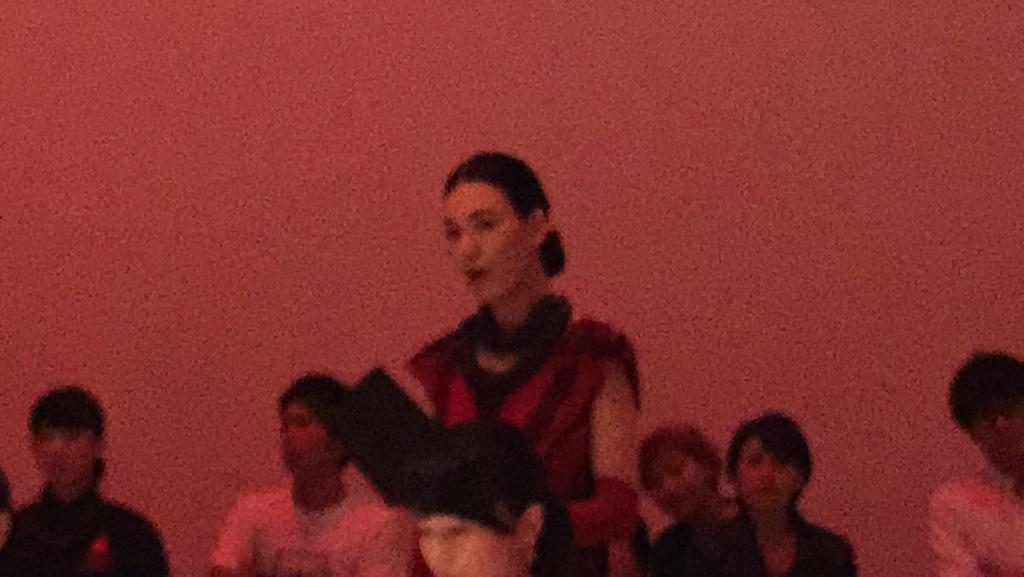What can be seen in the image? There is a group of people in the image, including a woman standing. What color is the background of the image? The background of the image is red. How is the image quality? The image is slightly blurred. What type of birds can be seen flying in the image? There are no birds visible in the image; it features a group of people and a red background. 